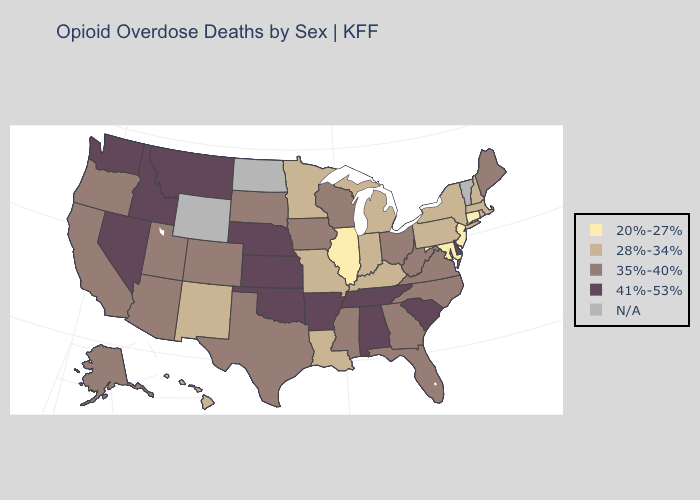What is the value of Minnesota?
Write a very short answer. 28%-34%. What is the highest value in states that border Nevada?
Short answer required. 41%-53%. Does Louisiana have the highest value in the South?
Short answer required. No. What is the value of Tennessee?
Quick response, please. 41%-53%. Name the states that have a value in the range 20%-27%?
Concise answer only. Connecticut, Illinois, Maryland, New Jersey. Which states have the lowest value in the South?
Short answer required. Maryland. What is the value of Massachusetts?
Answer briefly. 28%-34%. What is the value of Virginia?
Write a very short answer. 35%-40%. Name the states that have a value in the range N/A?
Concise answer only. North Dakota, Vermont, Wyoming. What is the highest value in states that border California?
Answer briefly. 41%-53%. What is the highest value in the USA?
Concise answer only. 41%-53%. What is the highest value in the South ?
Write a very short answer. 41%-53%. Name the states that have a value in the range 41%-53%?
Be succinct. Alabama, Arkansas, Delaware, Idaho, Kansas, Montana, Nebraska, Nevada, Oklahoma, South Carolina, Tennessee, Washington. What is the value of Louisiana?
Write a very short answer. 28%-34%. 